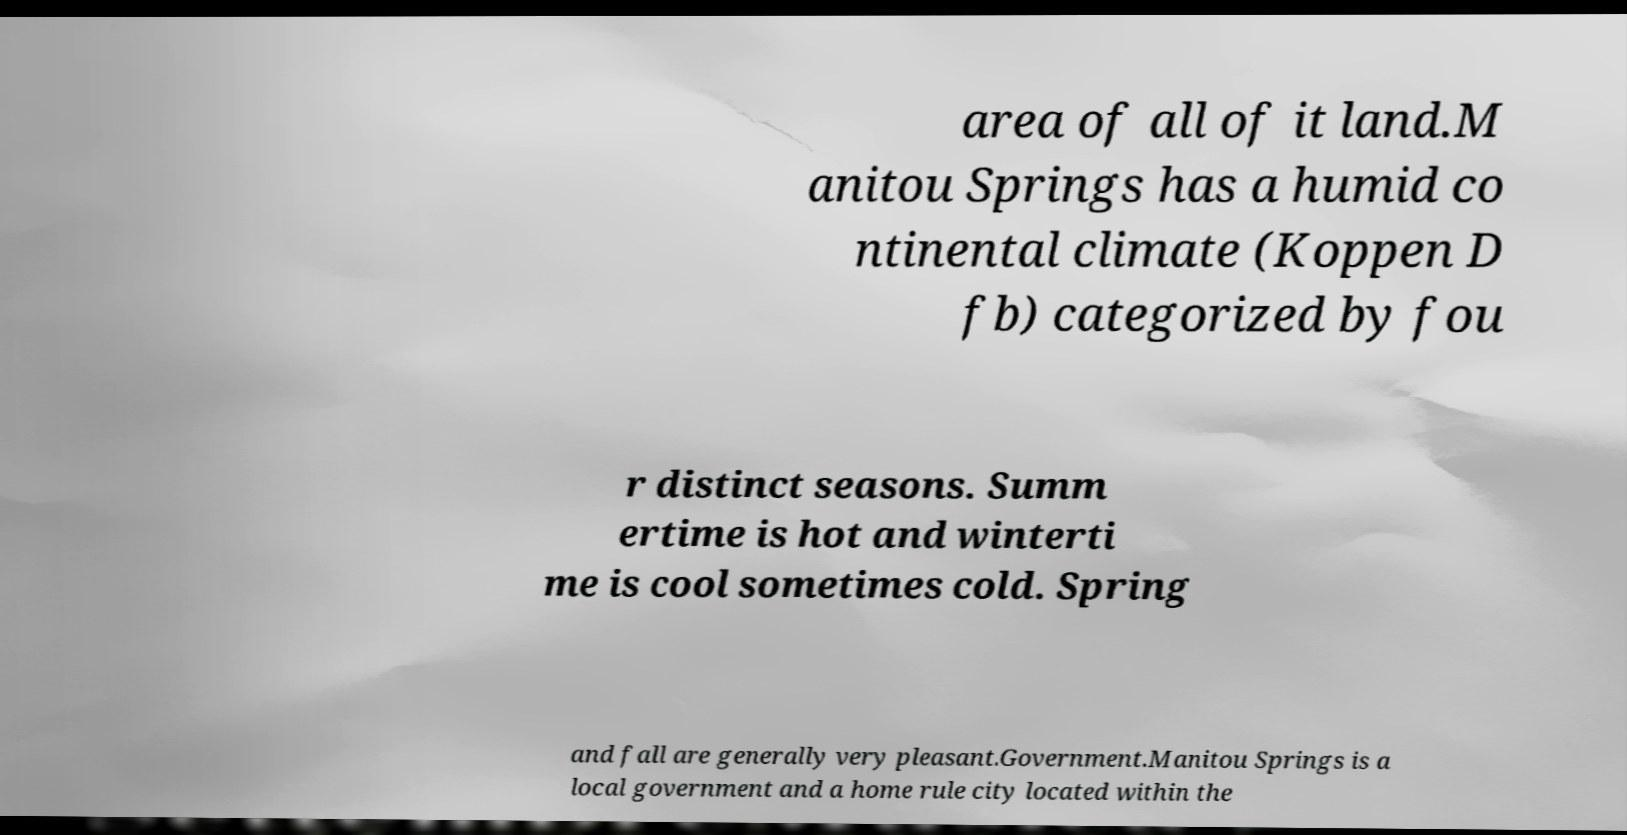Can you read and provide the text displayed in the image?This photo seems to have some interesting text. Can you extract and type it out for me? area of all of it land.M anitou Springs has a humid co ntinental climate (Koppen D fb) categorized by fou r distinct seasons. Summ ertime is hot and winterti me is cool sometimes cold. Spring and fall are generally very pleasant.Government.Manitou Springs is a local government and a home rule city located within the 